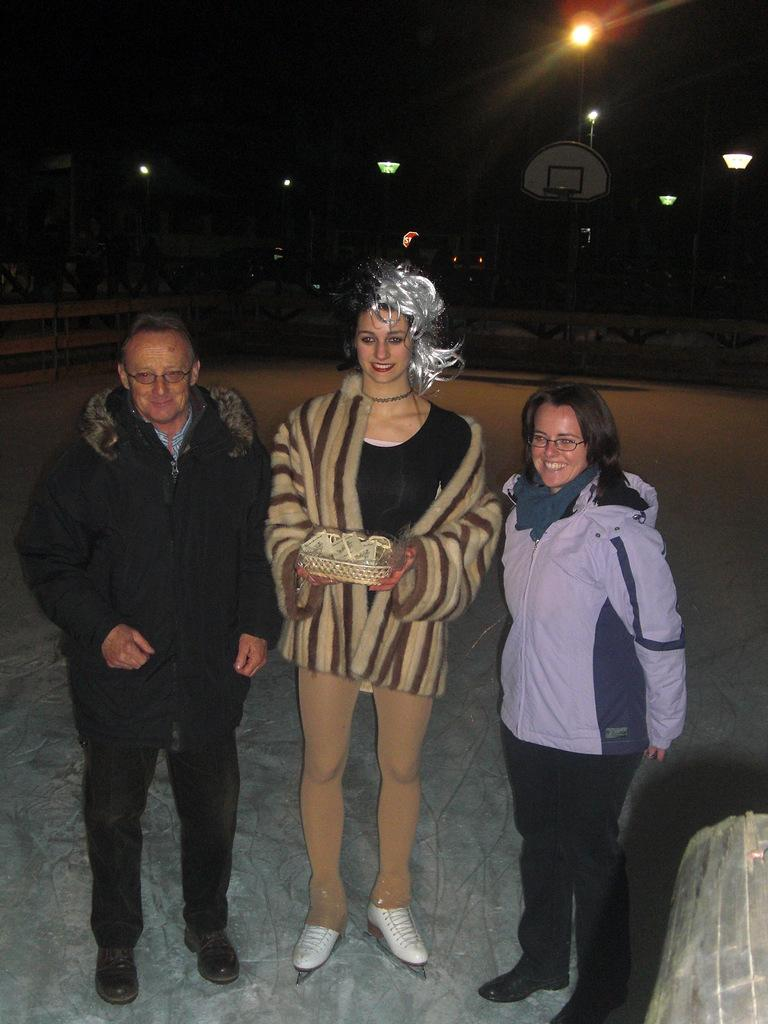How many people are in the image? There are three people in the middle of the image. What can be seen in the right corner of the image? There is an object in the right corner of the image. What is visible in the background of the image? There are lights visible in the background of the image. What is the color of the background in the image? The background has a black color. What type of jar is being used to hold the thread in the image? There is no jar or thread present in the image. 